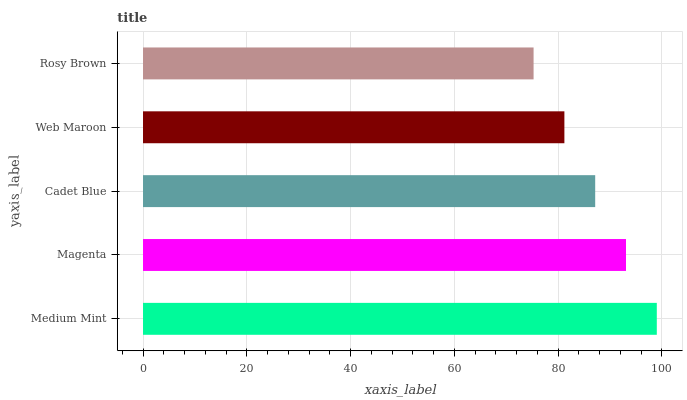Is Rosy Brown the minimum?
Answer yes or no. Yes. Is Medium Mint the maximum?
Answer yes or no. Yes. Is Magenta the minimum?
Answer yes or no. No. Is Magenta the maximum?
Answer yes or no. No. Is Medium Mint greater than Magenta?
Answer yes or no. Yes. Is Magenta less than Medium Mint?
Answer yes or no. Yes. Is Magenta greater than Medium Mint?
Answer yes or no. No. Is Medium Mint less than Magenta?
Answer yes or no. No. Is Cadet Blue the high median?
Answer yes or no. Yes. Is Cadet Blue the low median?
Answer yes or no. Yes. Is Magenta the high median?
Answer yes or no. No. Is Rosy Brown the low median?
Answer yes or no. No. 